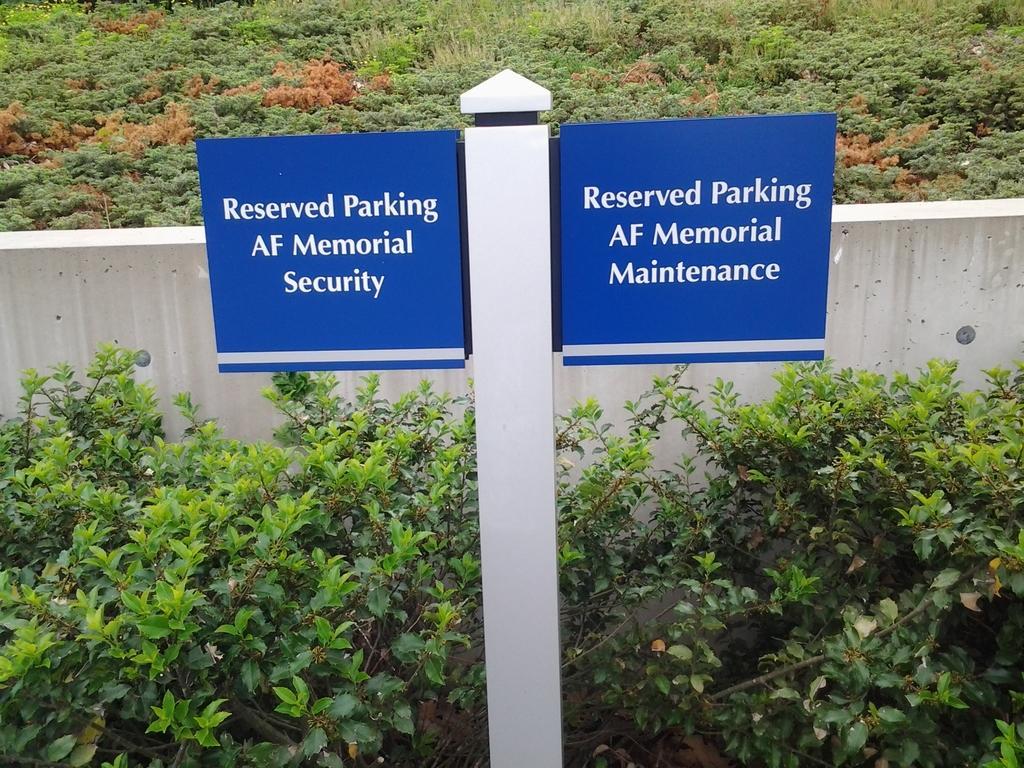Describe this image in one or two sentences. In the image we can see pole with two boards. Here we can see plant, wall and grass. 